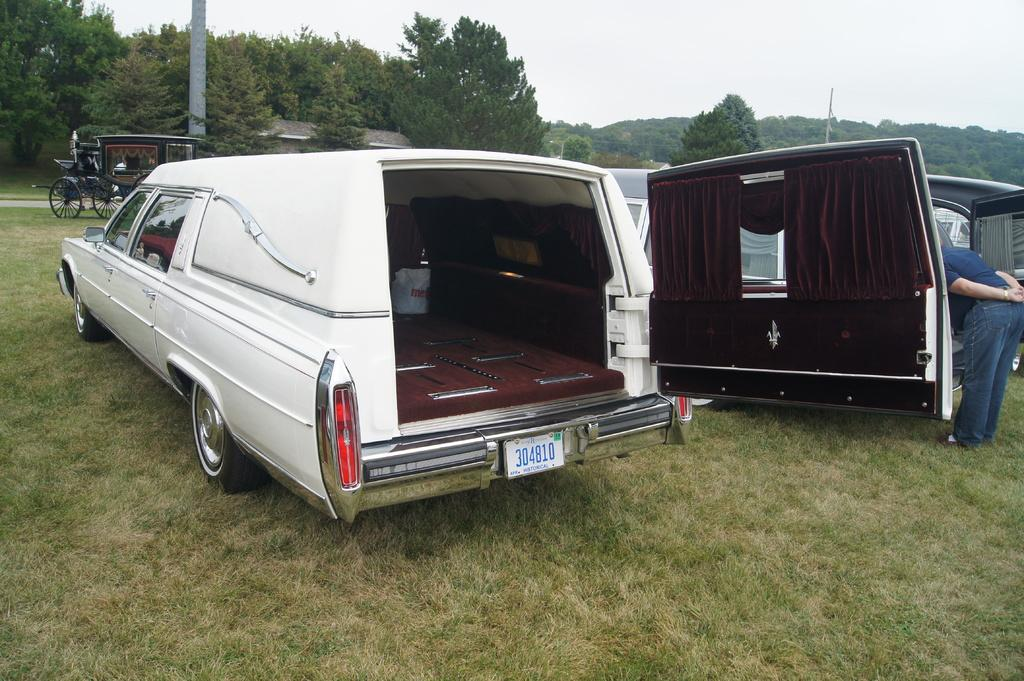What types of objects are in the image? There are vehicles in the image. Can you describe the person in the image? There is a person standing on the ground in the image. What type of vegetation is present in the image? Trees are present in the image. What is the ground made of in the image? Grass is visible in the image. What can be seen in the background of the image? The sky is visible in the background of the image. What time of day is it in the image, and is the person riding a carriage? The time of day is not mentioned in the image, and there is no carriage present. 